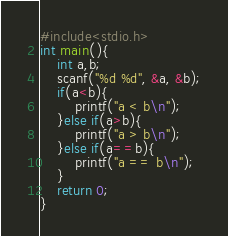Convert code to text. <code><loc_0><loc_0><loc_500><loc_500><_C_>#include<stdio.h>
int main(){
	int a,b;
	scanf("%d %d", &a, &b);
	if(a<b){
		printf("a < b\n");
	}else if(a>b){
		printf("a > b\n");
	}else if(a==b){
		printf("a == b\n");
	}
	return 0;
}</code> 